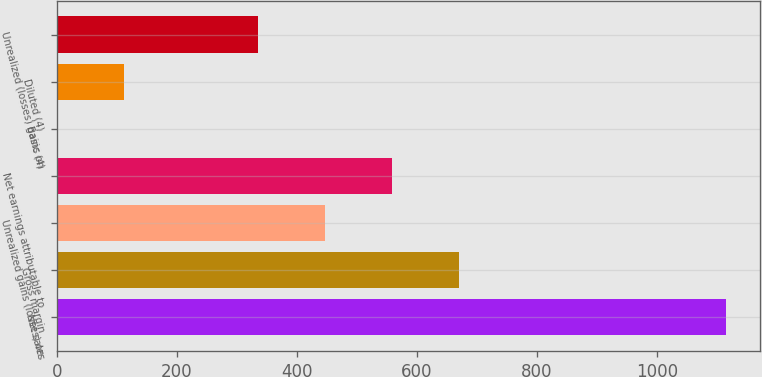Convert chart to OTSL. <chart><loc_0><loc_0><loc_500><loc_500><bar_chart><fcel>Net sales<fcel>Gross margin<fcel>Unrealized gains (losses) on<fcel>Net earnings attributable to<fcel>Basic (4)<fcel>Diluted (4)<fcel>Unrealized (losses) gains on<nl><fcel>1115.8<fcel>669.53<fcel>446.39<fcel>557.96<fcel>0.11<fcel>111.68<fcel>334.82<nl></chart> 